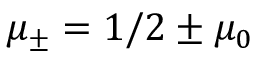<formula> <loc_0><loc_0><loc_500><loc_500>\mu _ { \pm } = 1 / 2 \pm \mu _ { 0 }</formula> 